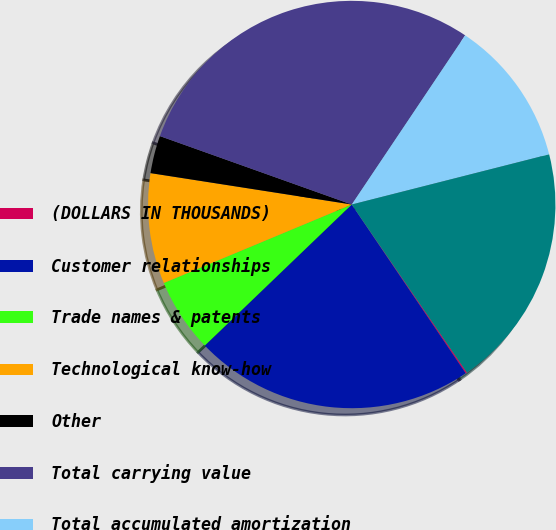Convert chart. <chart><loc_0><loc_0><loc_500><loc_500><pie_chart><fcel>(DOLLARS IN THOUSANDS)<fcel>Customer relationships<fcel>Trade names & patents<fcel>Technological know-how<fcel>Other<fcel>Total carrying value<fcel>Total accumulated amortization<fcel>Other intangible assets net<nl><fcel>0.11%<fcel>22.28%<fcel>5.88%<fcel>8.76%<fcel>2.99%<fcel>28.95%<fcel>11.64%<fcel>19.4%<nl></chart> 